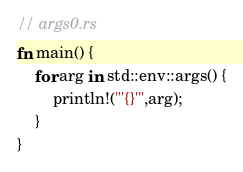Convert code to text. <code><loc_0><loc_0><loc_500><loc_500><_Rust_>// args0.rs
fn main() {
    for arg in std::env::args() {
        println!("'{}'",arg);
    }
}
</code> 